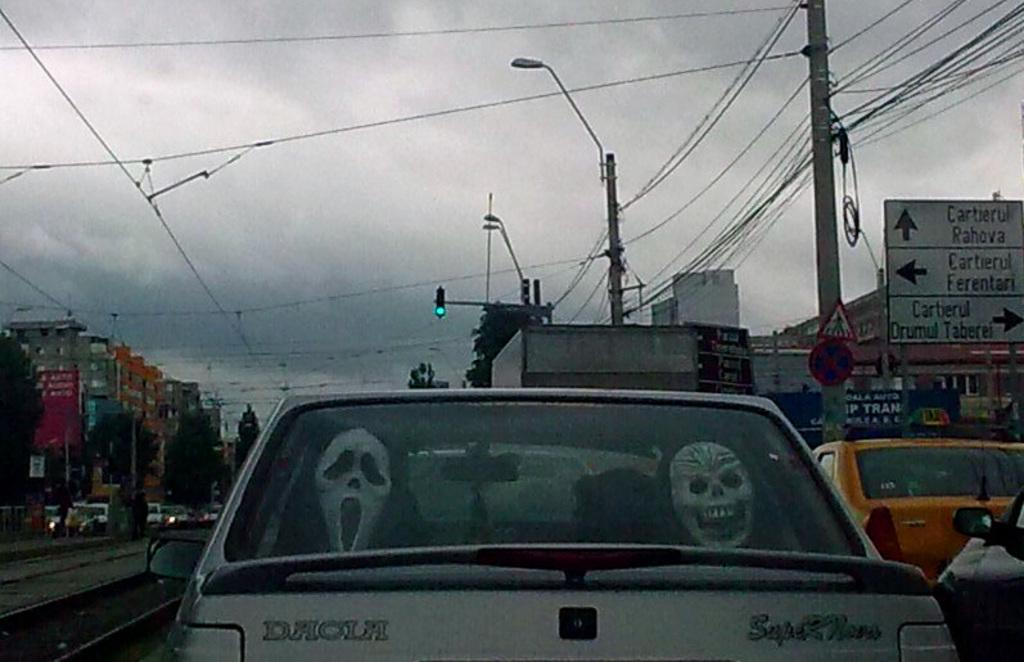<image>
Summarize the visual content of the image. Some Halloween masks are in the back of a SuperNova car. 